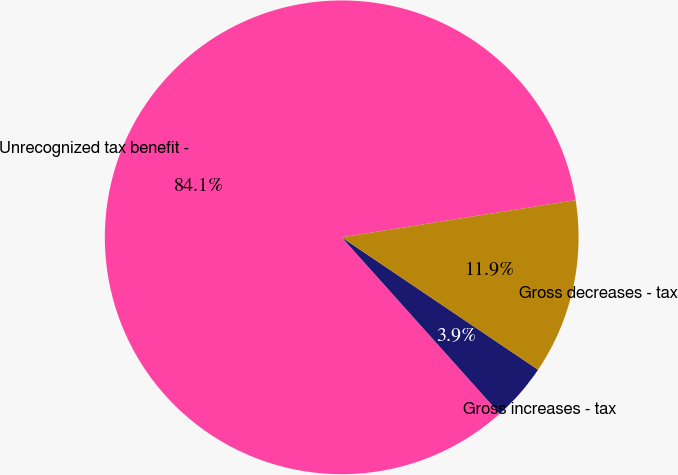<chart> <loc_0><loc_0><loc_500><loc_500><pie_chart><fcel>Unrecognized tax benefit -<fcel>Gross increases - tax<fcel>Gross decreases - tax<nl><fcel>84.12%<fcel>3.93%<fcel>11.95%<nl></chart> 